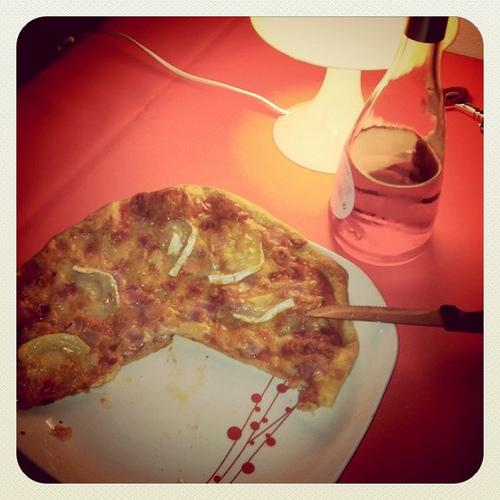Looking at the image, identify the central object and its immediate surroundings. The central object is a partially eaten pizza atop a white plate with red decorations, surrounded by a knife and a red table. Enumerate the primary elements in the photo and their corresponding properties. 3. Knife with black handle Present a succinct overview of the main element in the image and any accompanying items. The image centers upon a half-eaten pizza, adorned with tasty toppings, situated on an artistically designed plate alongside a knife with a black handle. What are the most significant elements in the image and their primary features? The image highlights a half-eaten pizza with cheese and mushroom toppings, accompanied by a black handled knife on a white plate with red decorations. Provide a concise synopsis of the image's main focal point. The image showcases a pizza with missing pieces placed on an intricately designed white and red plate on a red table and a knife resting on the plate. Briefly describe the central scene in the image, including any significant objects. The image portrays a partially eaten pizza with cheese and mushrooms on a decorative plate, featuring a knife with a black handle beside it. Provide a brief description of the main focus in the image. A partially eaten pizza with various toppings lies on a white and red plate on a red table, with a knife on the plate. What is the most prominent subject within the image and their defining characteristics? The most prominent subject is the pizza with cheese and mushroom toppings, characterized by its partially eaten state and placement on a decorative white and red plate. Using descriptive language, offer a snapshot of the image's centerpiece and accompanying details. A scrumptious pizza, garnished with cheese and mushrooms, is temptingly displayed on an ornate white and red plate, accompanied by a sleek knife with a black handle. List 3 objects present in the image and their colors. Pizza with cheese and mushroom toppings, white and red plate, and a knife with a black handle. 